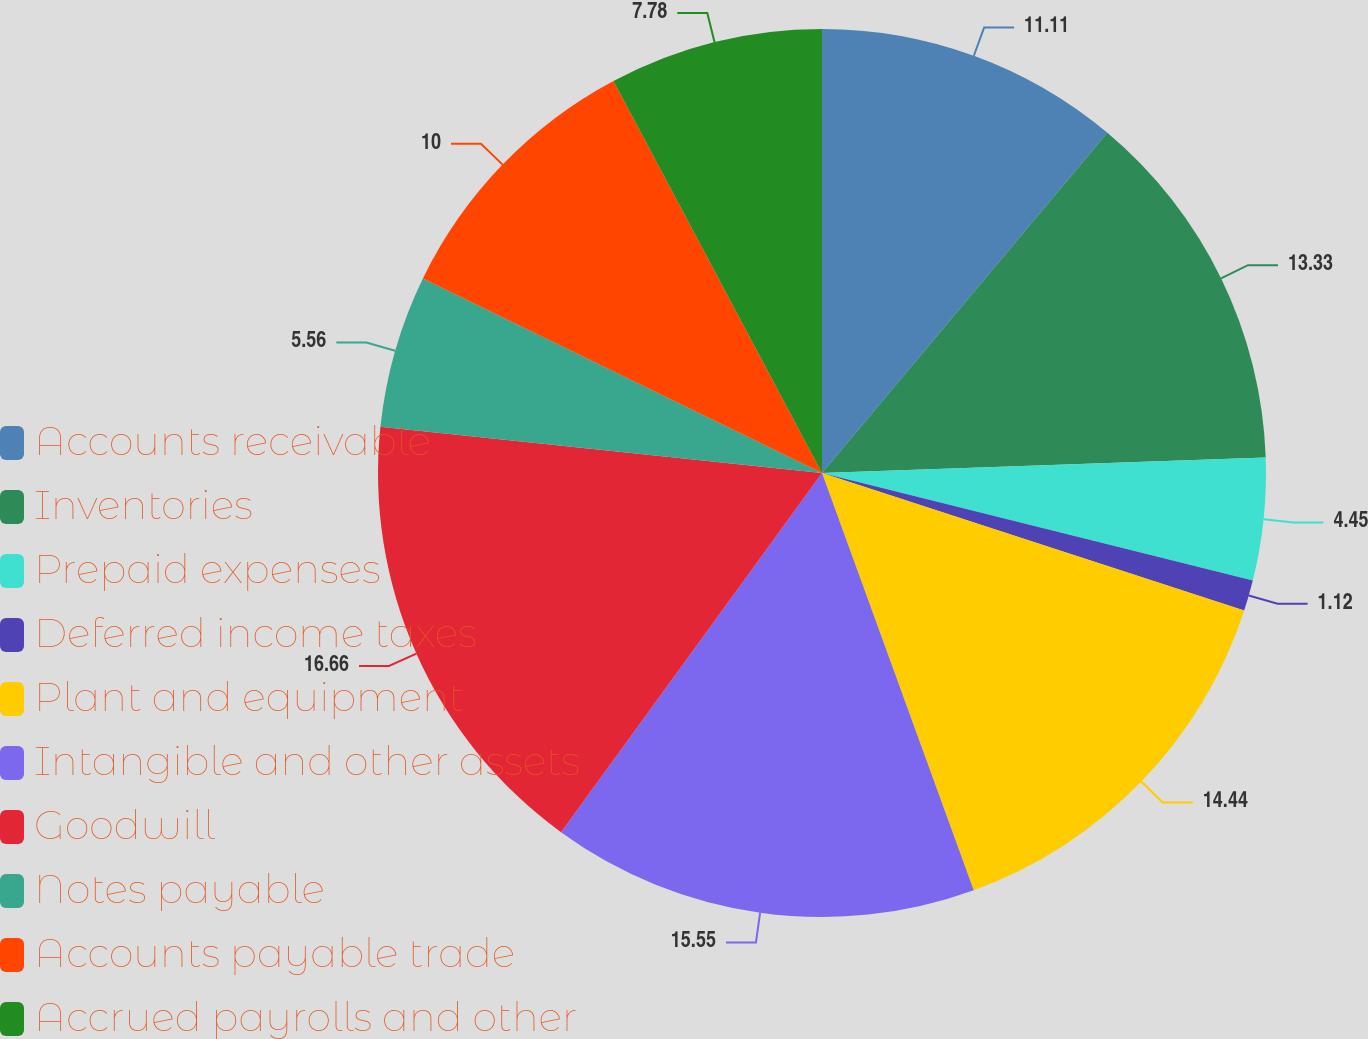Convert chart. <chart><loc_0><loc_0><loc_500><loc_500><pie_chart><fcel>Accounts receivable<fcel>Inventories<fcel>Prepaid expenses<fcel>Deferred income taxes<fcel>Plant and equipment<fcel>Intangible and other assets<fcel>Goodwill<fcel>Notes payable<fcel>Accounts payable trade<fcel>Accrued payrolls and other<nl><fcel>11.11%<fcel>13.33%<fcel>4.45%<fcel>1.12%<fcel>14.44%<fcel>15.55%<fcel>16.66%<fcel>5.56%<fcel>10.0%<fcel>7.78%<nl></chart> 